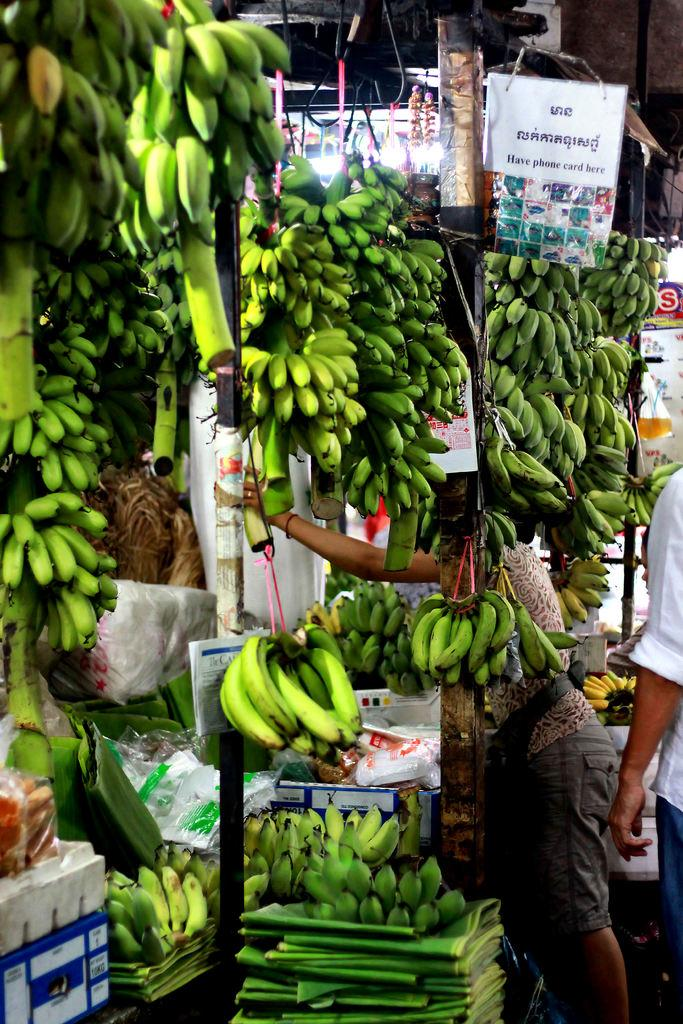What type of fruit is visible in the image? There are clusters of bananas in the image. Who or what else is present in the image? There are people in the image. What else can be seen on the walls or surfaces in the image? There are posters in the image. What type of hat is the person wearing in the image? There is no person wearing a hat in the image. What type of twig can be seen in the image? There is no twig present in the image. 